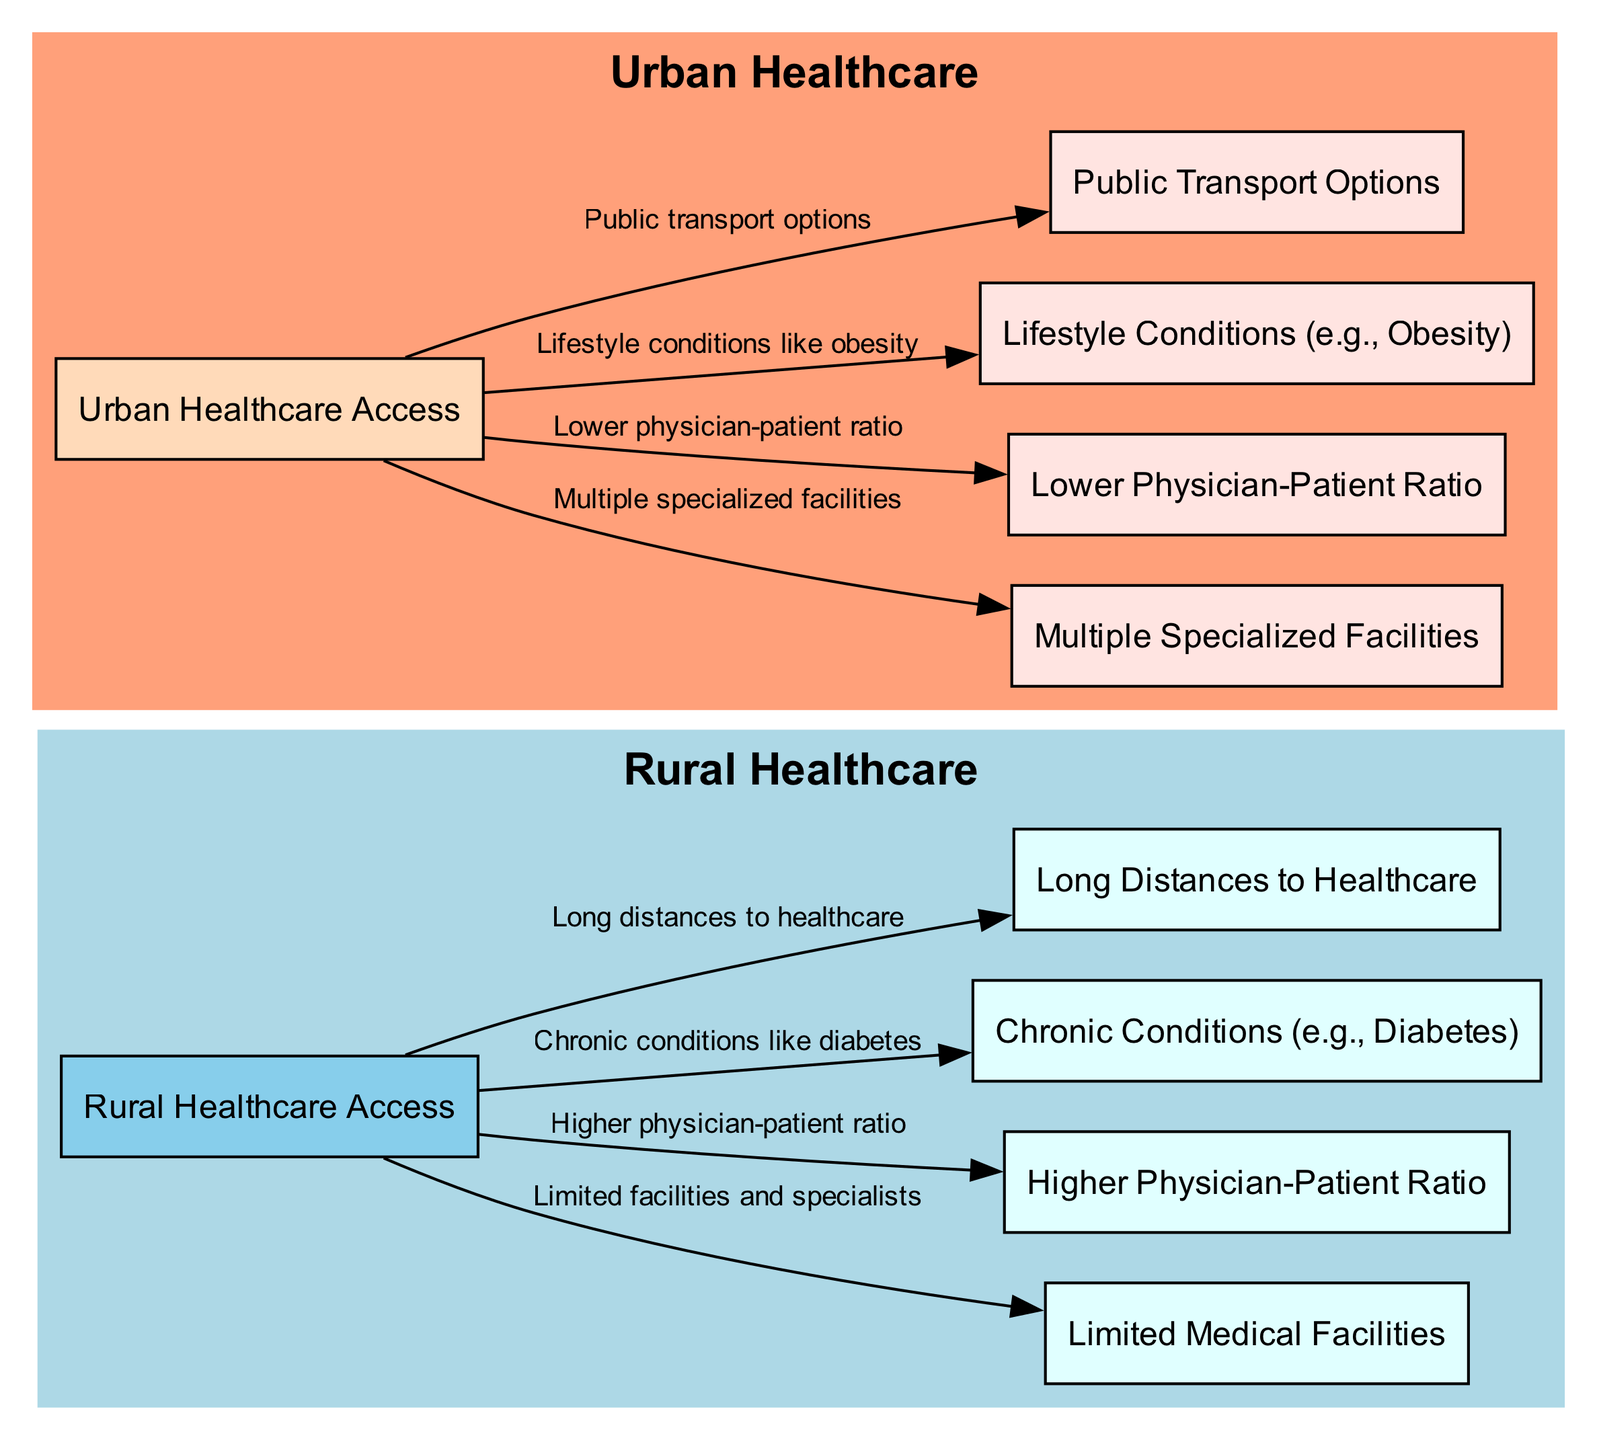What is the label of the node representing rural healthcare access? The node that indicates rural healthcare access has the label "Rural Healthcare Access." This is found in the section labeled "Rural Healthcare."
Answer: Rural Healthcare Access How many nodes are present in the diagram? By counting all the individual nodes listed in the data set, there are ten total nodes depicted in the diagram for both rural and urban healthcare.
Answer: 10 What type of healthcare conditions are more common in urban areas? The information in the diagram indicates that urban areas experience "Lifestyle conditions like obesity" as common health conditions. This is associated with the urban healthcare node.
Answer: Lifestyle conditions like obesity What does the rural healthcare node connect to that highlights transportation issues? The rural healthcare node connects to the "Long distances to healthcare" node, emphasizing the transportation challenges faced in rural areas.
Answer: Long distances to healthcare Which area has a higher physician-patient ratio, rural or urban? The diagram shows that the rural healthcare access node connects to "Higher physician-patient ratio," indicating that rural areas have a better ratio of physicians to patients compared to urban areas.
Answer: Higher physician-patient ratio What is the relationship between urban healthcare and transportation availability? The urban healthcare node is connected to "Public transport options," which indicates that transportation is generally more accessible in urban settings compared to rural settings.
Answer: Public transport options Why do rural areas often have limited medical facilities? The diagram implies that rural areas are characterized by "Limited facilities and specialists," explaining the healthcare challenges they face in accessing medical care.
Answer: Limited facilities and specialists What are two types of health conditions explicitly mentioned in the diagram? The diagram lists "Chronic conditions like diabetes" for rural areas and "Lifestyle conditions like obesity" for urban areas, showing the differing health concerns in these settings.
Answer: Chronic conditions like diabetes, Lifestyle conditions like obesity 